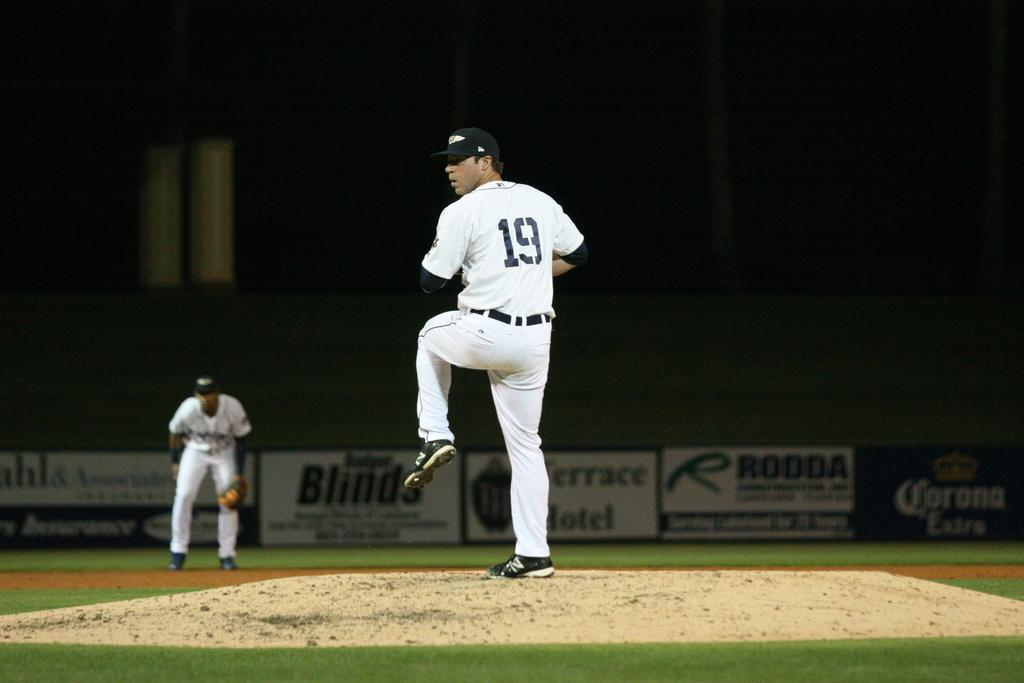<image>
Render a clear and concise summary of the photo. the number 19 player getting ready to pitch 